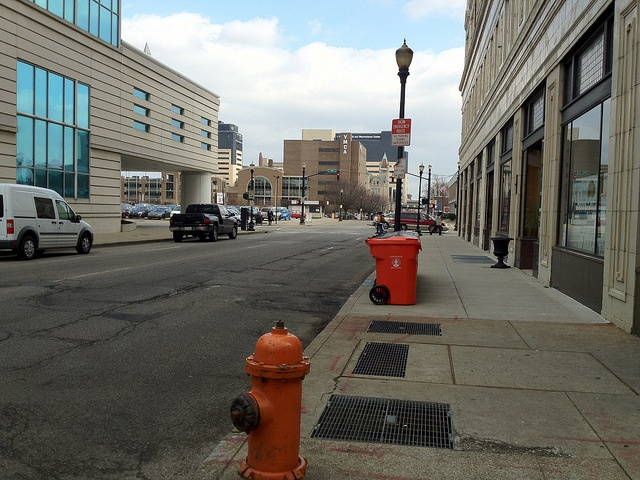Describe the objects in this image and their specific colors. I can see fire hydrant in gray, maroon, black, and brown tones, truck in gray, black, and darkgray tones, car in gray, black, and darkgray tones, truck in gray, black, darkgray, and maroon tones, and car in gray, black, maroon, and darkgray tones in this image. 